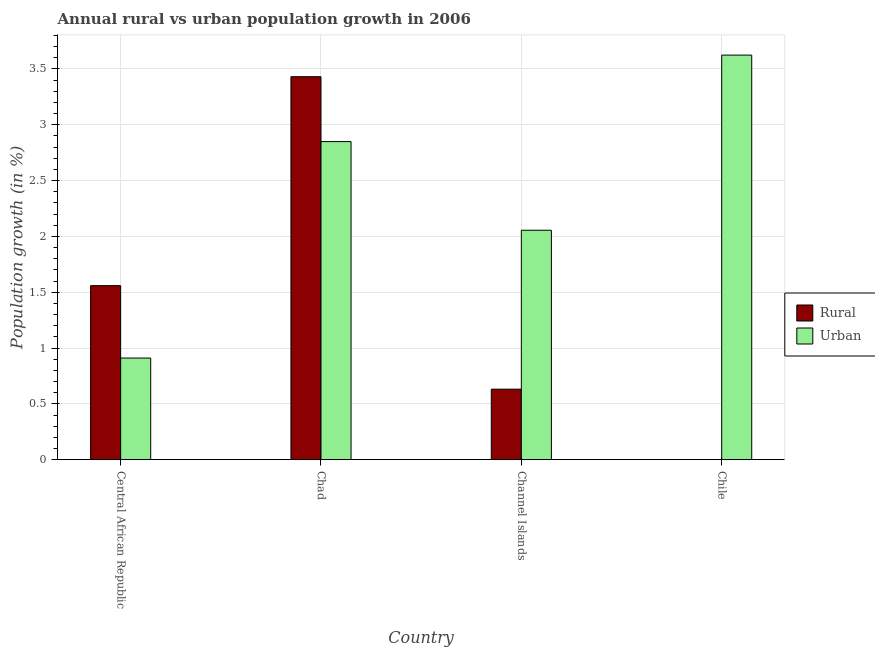How many different coloured bars are there?
Provide a succinct answer. 2. How many bars are there on the 3rd tick from the left?
Give a very brief answer. 2. How many bars are there on the 4th tick from the right?
Provide a short and direct response. 2. What is the label of the 1st group of bars from the left?
Your response must be concise. Central African Republic. In how many cases, is the number of bars for a given country not equal to the number of legend labels?
Your answer should be compact. 1. What is the urban population growth in Chad?
Offer a terse response. 2.85. Across all countries, what is the maximum rural population growth?
Offer a terse response. 3.43. Across all countries, what is the minimum urban population growth?
Your response must be concise. 0.91. In which country was the rural population growth maximum?
Provide a succinct answer. Chad. What is the total urban population growth in the graph?
Provide a succinct answer. 9.44. What is the difference between the rural population growth in Central African Republic and that in Chad?
Give a very brief answer. -1.87. What is the difference between the rural population growth in Chad and the urban population growth in Channel Islands?
Provide a short and direct response. 1.38. What is the average urban population growth per country?
Give a very brief answer. 2.36. What is the difference between the urban population growth and rural population growth in Central African Republic?
Give a very brief answer. -0.65. What is the ratio of the urban population growth in Central African Republic to that in Chile?
Your response must be concise. 0.25. Is the urban population growth in Central African Republic less than that in Chad?
Offer a very short reply. Yes. Is the difference between the urban population growth in Central African Republic and Channel Islands greater than the difference between the rural population growth in Central African Republic and Channel Islands?
Provide a short and direct response. No. What is the difference between the highest and the second highest rural population growth?
Your answer should be compact. 1.87. What is the difference between the highest and the lowest urban population growth?
Provide a short and direct response. 2.71. Is the sum of the urban population growth in Channel Islands and Chile greater than the maximum rural population growth across all countries?
Your answer should be very brief. Yes. Are all the bars in the graph horizontal?
Your answer should be very brief. No. How many countries are there in the graph?
Your response must be concise. 4. What is the difference between two consecutive major ticks on the Y-axis?
Your response must be concise. 0.5. Are the values on the major ticks of Y-axis written in scientific E-notation?
Your answer should be compact. No. Does the graph contain grids?
Your answer should be compact. Yes. Where does the legend appear in the graph?
Your response must be concise. Center right. How are the legend labels stacked?
Make the answer very short. Vertical. What is the title of the graph?
Keep it short and to the point. Annual rural vs urban population growth in 2006. Does "Food" appear as one of the legend labels in the graph?
Provide a succinct answer. No. What is the label or title of the X-axis?
Keep it short and to the point. Country. What is the label or title of the Y-axis?
Provide a short and direct response. Population growth (in %). What is the Population growth (in %) of Rural in Central African Republic?
Ensure brevity in your answer.  1.56. What is the Population growth (in %) of Urban  in Central African Republic?
Your response must be concise. 0.91. What is the Population growth (in %) in Rural in Chad?
Keep it short and to the point. 3.43. What is the Population growth (in %) of Urban  in Chad?
Offer a very short reply. 2.85. What is the Population growth (in %) in Rural in Channel Islands?
Give a very brief answer. 0.63. What is the Population growth (in %) of Urban  in Channel Islands?
Provide a short and direct response. 2.05. What is the Population growth (in %) of Rural in Chile?
Your response must be concise. 0. What is the Population growth (in %) in Urban  in Chile?
Give a very brief answer. 3.62. Across all countries, what is the maximum Population growth (in %) of Rural?
Give a very brief answer. 3.43. Across all countries, what is the maximum Population growth (in %) in Urban ?
Provide a succinct answer. 3.62. Across all countries, what is the minimum Population growth (in %) of Urban ?
Offer a terse response. 0.91. What is the total Population growth (in %) in Rural in the graph?
Offer a very short reply. 5.62. What is the total Population growth (in %) of Urban  in the graph?
Give a very brief answer. 9.44. What is the difference between the Population growth (in %) of Rural in Central African Republic and that in Chad?
Your answer should be very brief. -1.87. What is the difference between the Population growth (in %) of Urban  in Central African Republic and that in Chad?
Keep it short and to the point. -1.94. What is the difference between the Population growth (in %) of Rural in Central African Republic and that in Channel Islands?
Make the answer very short. 0.93. What is the difference between the Population growth (in %) in Urban  in Central African Republic and that in Channel Islands?
Provide a succinct answer. -1.14. What is the difference between the Population growth (in %) of Urban  in Central African Republic and that in Chile?
Make the answer very short. -2.71. What is the difference between the Population growth (in %) in Rural in Chad and that in Channel Islands?
Provide a short and direct response. 2.8. What is the difference between the Population growth (in %) of Urban  in Chad and that in Channel Islands?
Your response must be concise. 0.79. What is the difference between the Population growth (in %) of Urban  in Chad and that in Chile?
Ensure brevity in your answer.  -0.77. What is the difference between the Population growth (in %) of Urban  in Channel Islands and that in Chile?
Offer a terse response. -1.57. What is the difference between the Population growth (in %) in Rural in Central African Republic and the Population growth (in %) in Urban  in Chad?
Provide a short and direct response. -1.29. What is the difference between the Population growth (in %) in Rural in Central African Republic and the Population growth (in %) in Urban  in Channel Islands?
Your answer should be compact. -0.5. What is the difference between the Population growth (in %) in Rural in Central African Republic and the Population growth (in %) in Urban  in Chile?
Provide a succinct answer. -2.06. What is the difference between the Population growth (in %) in Rural in Chad and the Population growth (in %) in Urban  in Channel Islands?
Make the answer very short. 1.38. What is the difference between the Population growth (in %) of Rural in Chad and the Population growth (in %) of Urban  in Chile?
Provide a succinct answer. -0.19. What is the difference between the Population growth (in %) in Rural in Channel Islands and the Population growth (in %) in Urban  in Chile?
Provide a short and direct response. -2.99. What is the average Population growth (in %) in Rural per country?
Provide a succinct answer. 1.41. What is the average Population growth (in %) in Urban  per country?
Offer a terse response. 2.36. What is the difference between the Population growth (in %) of Rural and Population growth (in %) of Urban  in Central African Republic?
Provide a short and direct response. 0.65. What is the difference between the Population growth (in %) of Rural and Population growth (in %) of Urban  in Chad?
Provide a succinct answer. 0.58. What is the difference between the Population growth (in %) of Rural and Population growth (in %) of Urban  in Channel Islands?
Your response must be concise. -1.42. What is the ratio of the Population growth (in %) of Rural in Central African Republic to that in Chad?
Provide a succinct answer. 0.45. What is the ratio of the Population growth (in %) of Urban  in Central African Republic to that in Chad?
Keep it short and to the point. 0.32. What is the ratio of the Population growth (in %) in Rural in Central African Republic to that in Channel Islands?
Your response must be concise. 2.47. What is the ratio of the Population growth (in %) of Urban  in Central African Republic to that in Channel Islands?
Keep it short and to the point. 0.44. What is the ratio of the Population growth (in %) of Urban  in Central African Republic to that in Chile?
Your response must be concise. 0.25. What is the ratio of the Population growth (in %) of Rural in Chad to that in Channel Islands?
Keep it short and to the point. 5.43. What is the ratio of the Population growth (in %) in Urban  in Chad to that in Channel Islands?
Make the answer very short. 1.39. What is the ratio of the Population growth (in %) of Urban  in Chad to that in Chile?
Give a very brief answer. 0.79. What is the ratio of the Population growth (in %) in Urban  in Channel Islands to that in Chile?
Your answer should be compact. 0.57. What is the difference between the highest and the second highest Population growth (in %) of Rural?
Make the answer very short. 1.87. What is the difference between the highest and the second highest Population growth (in %) of Urban ?
Make the answer very short. 0.77. What is the difference between the highest and the lowest Population growth (in %) of Rural?
Ensure brevity in your answer.  3.43. What is the difference between the highest and the lowest Population growth (in %) of Urban ?
Your answer should be compact. 2.71. 